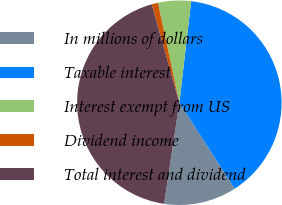Convert chart to OTSL. <chart><loc_0><loc_0><loc_500><loc_500><pie_chart><fcel>In millions of dollars<fcel>Taxable interest<fcel>Interest exempt from US<fcel>Dividend income<fcel>Total interest and dividend<nl><fcel>11.48%<fcel>39.05%<fcel>5.21%<fcel>1.0%<fcel>43.26%<nl></chart> 